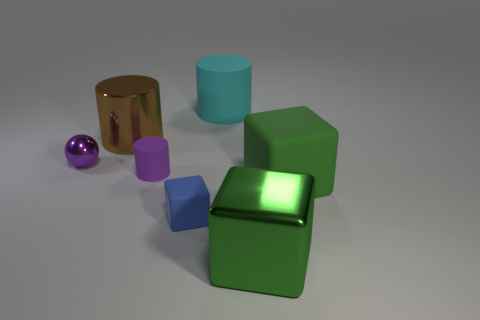What could be the purpose of arranging these objects in this manner? It's likely that these objects have been arranged for a visual exercise or display, possibly to showcase their shapes, colors, and textures. The arrangement allows viewers to compare and contrast the different properties of each item. It could serve an educational purpose or simply be an artistic composition to study the interplay of light and form. 